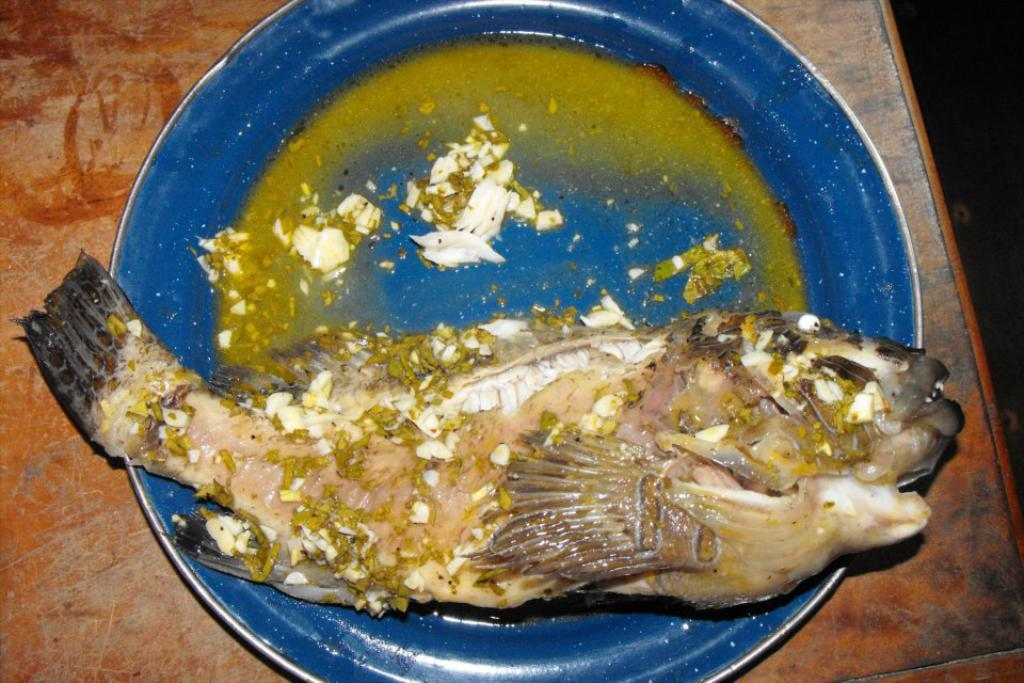What color is the plate in the image? The plate in the image is blue. What is on the plate in the image? There is a fish on the plate in the image. Where is the beggar in the image? There is no beggar present in the image. What type of stick is used to catch the fish in the image? There is no stick or fishing activity depicted in the image; it only shows a fish on a blue plate. 